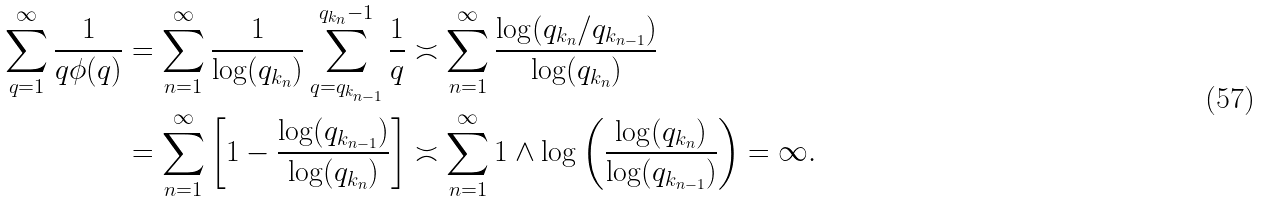Convert formula to latex. <formula><loc_0><loc_0><loc_500><loc_500>\sum _ { q = 1 } ^ { \infty } \frac { 1 } { q \phi ( q ) } & = \sum _ { n = 1 } ^ { \infty } \frac { 1 } { \log ( q _ { k _ { n } } ) } \sum _ { q = q _ { k _ { n - 1 } } } ^ { q _ { k _ { n } } - 1 } \frac { 1 } { q } \asymp \sum _ { n = 1 } ^ { \infty } \frac { \log ( q _ { k _ { n } } / q _ { k _ { n - 1 } } ) } { \log ( q _ { k _ { n } } ) } \\ & = \sum _ { n = 1 } ^ { \infty } \left [ 1 - \frac { \log ( q _ { k _ { n - 1 } } ) } { \log ( q _ { k _ { n } } ) } \right ] \asymp \sum _ { n = 1 } ^ { \infty } 1 \wedge \log \left ( \frac { \log ( q _ { k _ { n } } ) } { \log ( q _ { k _ { n - 1 } } ) } \right ) = \infty .</formula> 